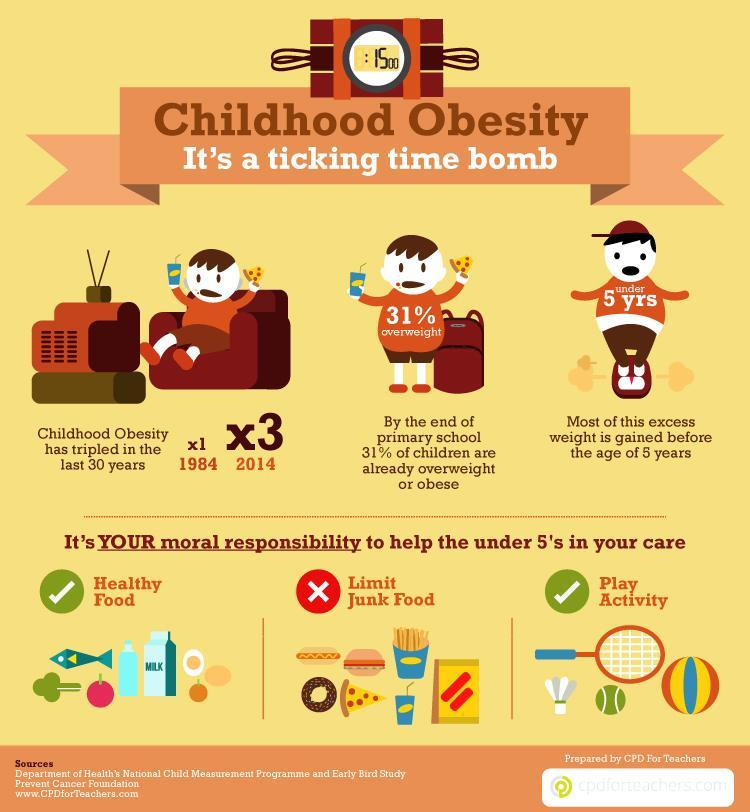How many children are in this infographic?
Answer the question with a short phrase. 3 What percentage of children are not overweight? 69% How many balls are in this infographic? 2 How many do's are in this infographic? 2 How many don'ts are in this infographic? 1 